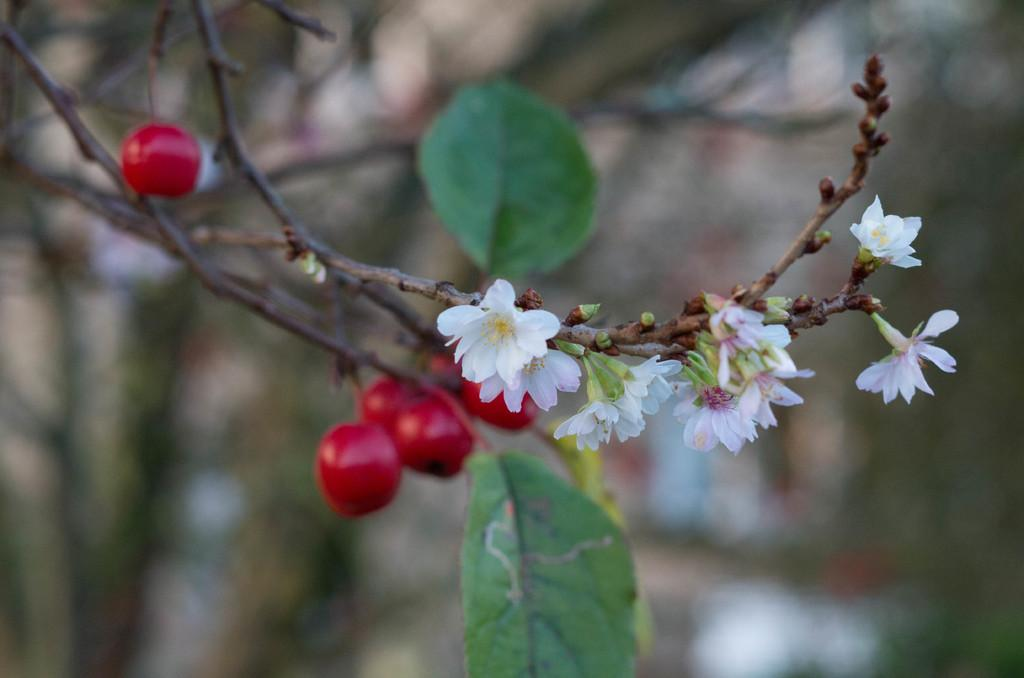What type of plant can be seen in the image? There is a tree in the image. What colors are present on the tree? The tree has red color fruits and white color flowers. What is the color of the leaves on the tree? The leaves on the tree are green. What type of temper does the tree have in the image? There is no indication of the tree having a temper in the image, as trees do not have emotions. 